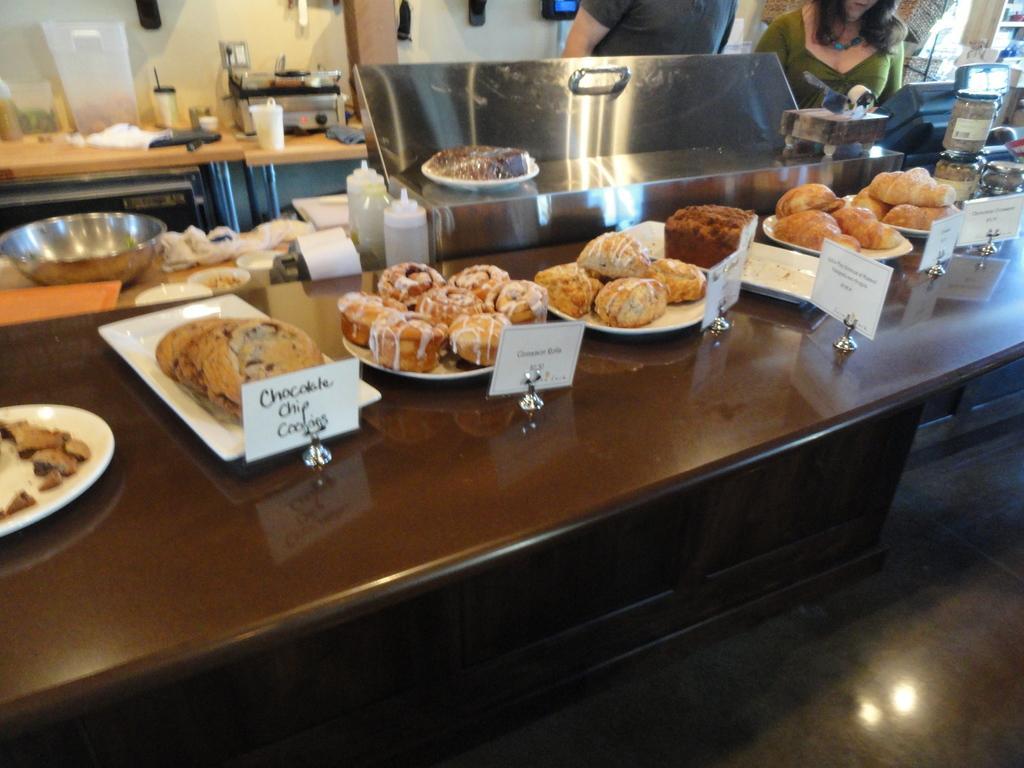Can you describe this image briefly? This is a table with a cookies,muffins and some other food items on the plates with name boards. Here I can see two persons standing. This is a big bowl and plastic bottles. Here I can see a electronic device which is used for baked goods. 